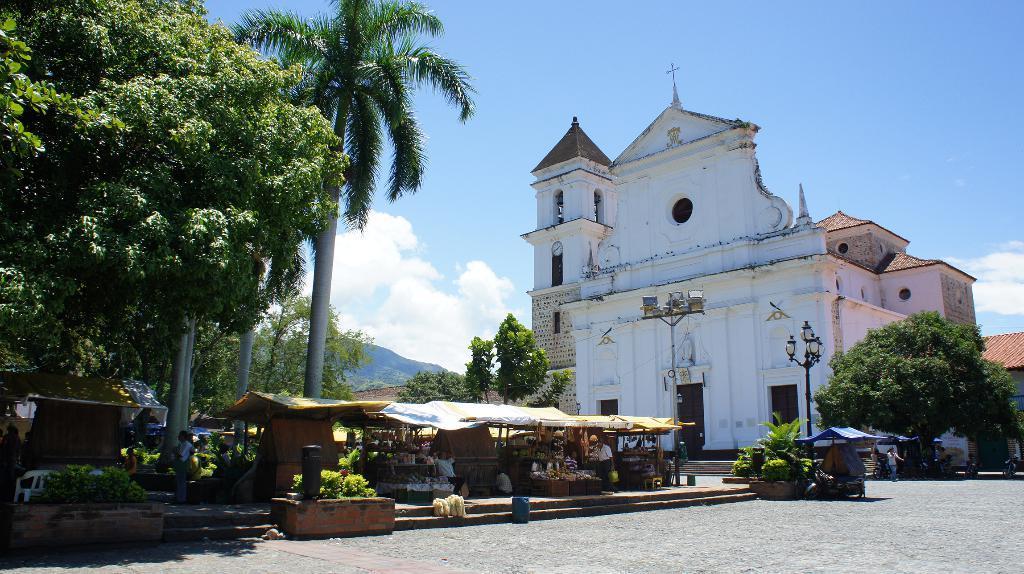How would you summarize this image in a sentence or two? In this image there is a building at right side of this image and there are some shops as we can see at bottom of this image and there are some trees in the background and there a mountain in middle of this image and there is a cloudy sky at top of this image and there are some persons standing at left side of this image and right side of this image as well. 